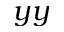Convert formula to latex. <formula><loc_0><loc_0><loc_500><loc_500>y y</formula> 